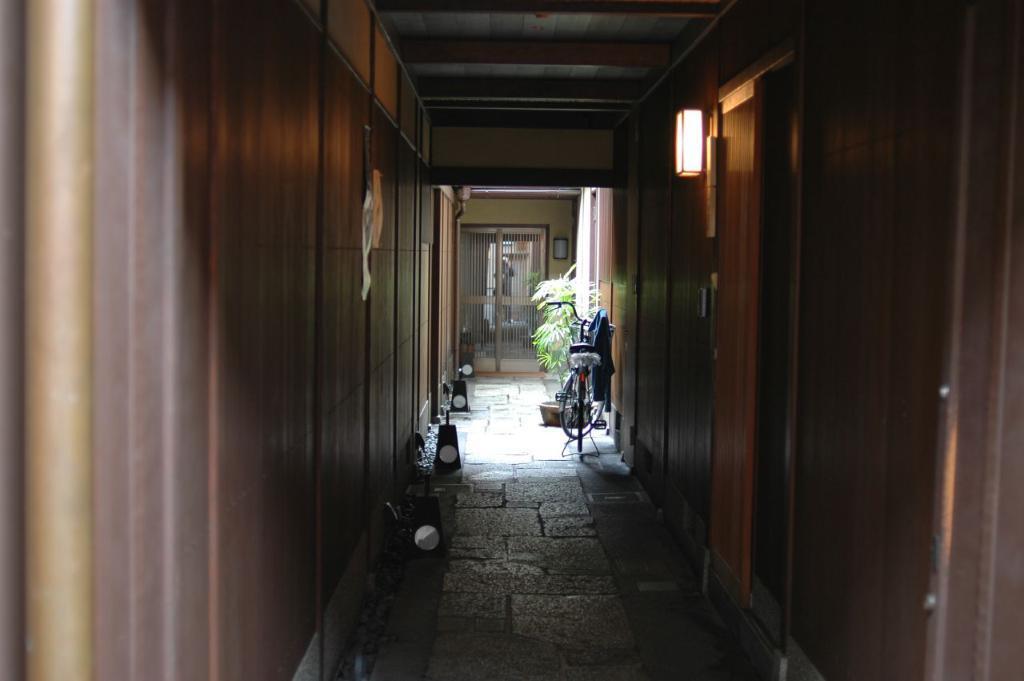In one or two sentences, can you explain what this image depicts? In this image we can see the wooden doors. And we can see the wooden walls. And we can see the windows. And we can see the lights. And we can see the bicycle and the flower pot. 